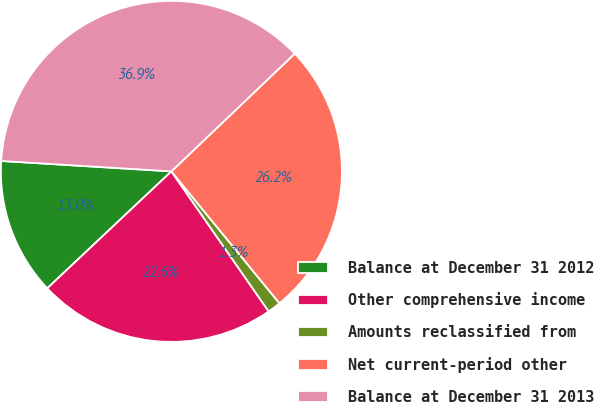Convert chart to OTSL. <chart><loc_0><loc_0><loc_500><loc_500><pie_chart><fcel>Balance at December 31 2012<fcel>Other comprehensive income<fcel>Amounts reclassified from<fcel>Net current-period other<fcel>Balance at December 31 2013<nl><fcel>13.0%<fcel>22.64%<fcel>1.26%<fcel>26.21%<fcel>36.9%<nl></chart> 